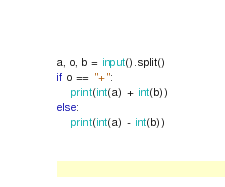Convert code to text. <code><loc_0><loc_0><loc_500><loc_500><_Python_>a, o, b = input().split()
if o == "+":
    print(int(a) + int(b))
else:
    print(int(a) - int(b))
</code> 